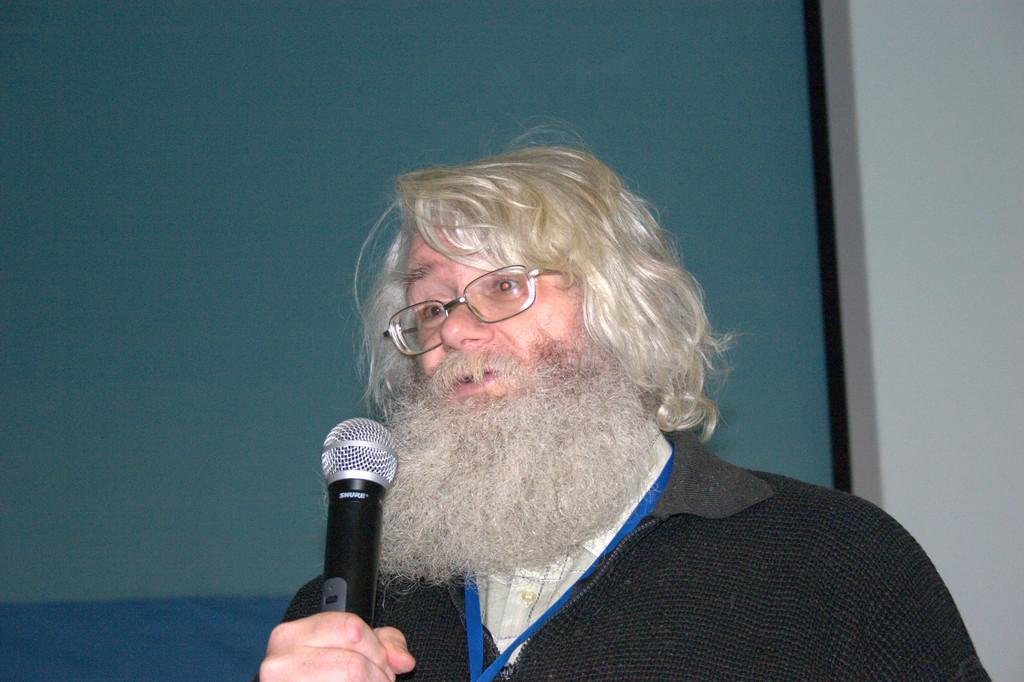Who or what is the main subject in the image? There is a person in the center of the image. What is the person holding in his hand? The person is holding a mic in his hand. Can you describe the background of the image? There is a green color screen in the background of the image. What type of fang can be seen in the person's mouth in the image? There is no fang visible in the person's mouth in the image. What type of art is displayed on the green screen in the background? The green screen in the background is a solid color and does not display any art. 